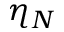<formula> <loc_0><loc_0><loc_500><loc_500>\eta _ { N }</formula> 